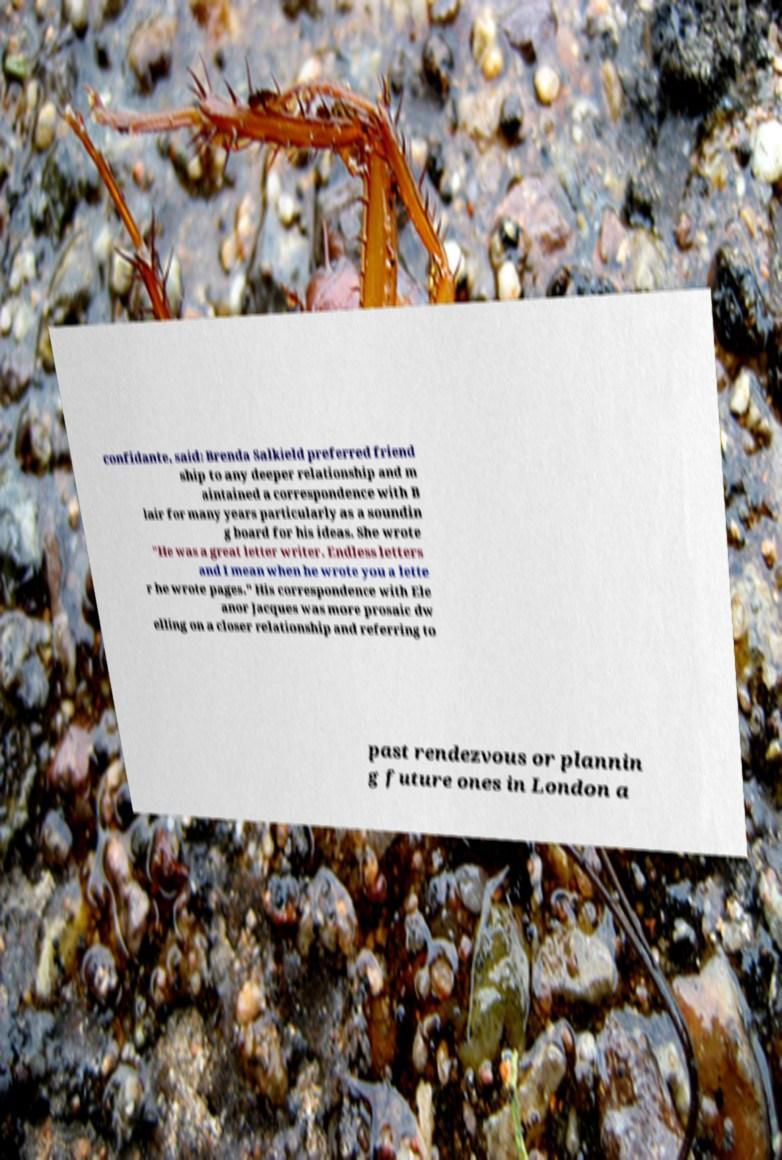Could you assist in decoding the text presented in this image and type it out clearly? confidante, said: Brenda Salkield preferred friend ship to any deeper relationship and m aintained a correspondence with B lair for many years particularly as a soundin g board for his ideas. She wrote "He was a great letter writer. Endless letters and I mean when he wrote you a lette r he wrote pages." His correspondence with Ele anor Jacques was more prosaic dw elling on a closer relationship and referring to past rendezvous or plannin g future ones in London a 